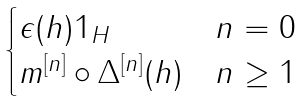<formula> <loc_0><loc_0><loc_500><loc_500>\begin{cases} \epsilon ( h ) 1 _ { H } & n = 0 \\ m ^ { [ n ] } \circ \Delta ^ { [ n ] } ( h ) & n \geq 1 \end{cases}</formula> 